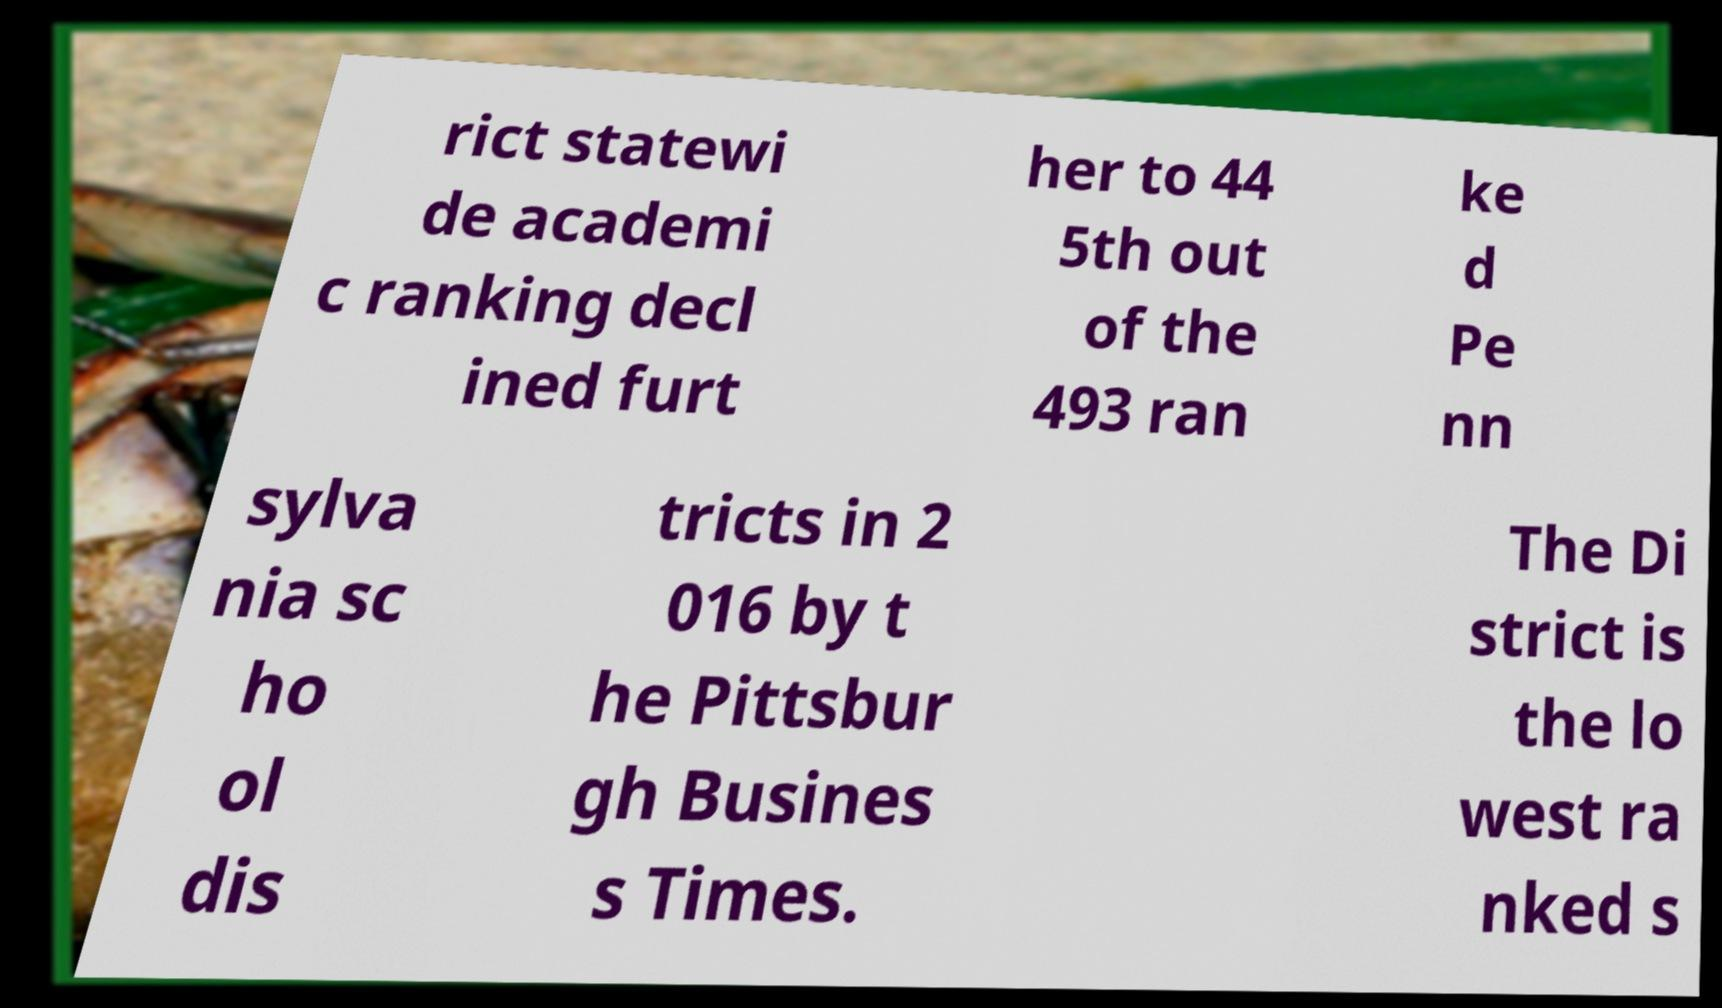For documentation purposes, I need the text within this image transcribed. Could you provide that? rict statewi de academi c ranking decl ined furt her to 44 5th out of the 493 ran ke d Pe nn sylva nia sc ho ol dis tricts in 2 016 by t he Pittsbur gh Busines s Times. The Di strict is the lo west ra nked s 